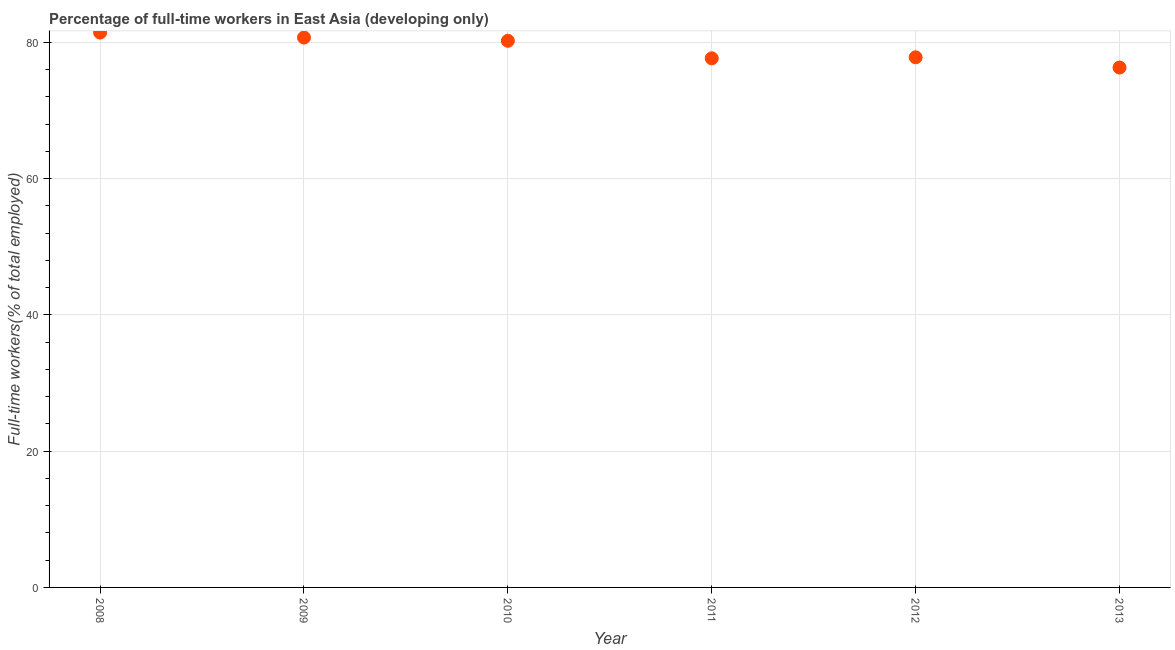What is the percentage of full-time workers in 2009?
Provide a short and direct response. 80.71. Across all years, what is the maximum percentage of full-time workers?
Provide a short and direct response. 81.44. Across all years, what is the minimum percentage of full-time workers?
Keep it short and to the point. 76.31. In which year was the percentage of full-time workers maximum?
Your response must be concise. 2008. In which year was the percentage of full-time workers minimum?
Offer a very short reply. 2013. What is the sum of the percentage of full-time workers?
Your response must be concise. 474.18. What is the difference between the percentage of full-time workers in 2010 and 2011?
Your answer should be compact. 2.57. What is the average percentage of full-time workers per year?
Offer a terse response. 79.03. What is the median percentage of full-time workers?
Keep it short and to the point. 79.03. In how many years, is the percentage of full-time workers greater than 12 %?
Keep it short and to the point. 6. Do a majority of the years between 2013 and 2011 (inclusive) have percentage of full-time workers greater than 68 %?
Keep it short and to the point. No. What is the ratio of the percentage of full-time workers in 2009 to that in 2013?
Your answer should be compact. 1.06. Is the percentage of full-time workers in 2008 less than that in 2013?
Provide a short and direct response. No. Is the difference between the percentage of full-time workers in 2008 and 2011 greater than the difference between any two years?
Keep it short and to the point. No. What is the difference between the highest and the second highest percentage of full-time workers?
Ensure brevity in your answer.  0.73. What is the difference between the highest and the lowest percentage of full-time workers?
Offer a very short reply. 5.13. In how many years, is the percentage of full-time workers greater than the average percentage of full-time workers taken over all years?
Your answer should be very brief. 3. Does the percentage of full-time workers monotonically increase over the years?
Make the answer very short. No. How many dotlines are there?
Your answer should be compact. 1. What is the difference between two consecutive major ticks on the Y-axis?
Offer a terse response. 20. Are the values on the major ticks of Y-axis written in scientific E-notation?
Ensure brevity in your answer.  No. What is the title of the graph?
Your response must be concise. Percentage of full-time workers in East Asia (developing only). What is the label or title of the X-axis?
Provide a succinct answer. Year. What is the label or title of the Y-axis?
Keep it short and to the point. Full-time workers(% of total employed). What is the Full-time workers(% of total employed) in 2008?
Provide a short and direct response. 81.44. What is the Full-time workers(% of total employed) in 2009?
Offer a terse response. 80.71. What is the Full-time workers(% of total employed) in 2010?
Keep it short and to the point. 80.24. What is the Full-time workers(% of total employed) in 2011?
Offer a terse response. 77.66. What is the Full-time workers(% of total employed) in 2012?
Keep it short and to the point. 77.81. What is the Full-time workers(% of total employed) in 2013?
Your response must be concise. 76.31. What is the difference between the Full-time workers(% of total employed) in 2008 and 2009?
Your response must be concise. 0.73. What is the difference between the Full-time workers(% of total employed) in 2008 and 2010?
Your answer should be compact. 1.21. What is the difference between the Full-time workers(% of total employed) in 2008 and 2011?
Your answer should be compact. 3.78. What is the difference between the Full-time workers(% of total employed) in 2008 and 2012?
Your answer should be very brief. 3.63. What is the difference between the Full-time workers(% of total employed) in 2008 and 2013?
Make the answer very short. 5.13. What is the difference between the Full-time workers(% of total employed) in 2009 and 2010?
Offer a terse response. 0.48. What is the difference between the Full-time workers(% of total employed) in 2009 and 2011?
Provide a succinct answer. 3.05. What is the difference between the Full-time workers(% of total employed) in 2009 and 2012?
Make the answer very short. 2.9. What is the difference between the Full-time workers(% of total employed) in 2009 and 2013?
Offer a terse response. 4.4. What is the difference between the Full-time workers(% of total employed) in 2010 and 2011?
Keep it short and to the point. 2.57. What is the difference between the Full-time workers(% of total employed) in 2010 and 2012?
Offer a terse response. 2.42. What is the difference between the Full-time workers(% of total employed) in 2010 and 2013?
Your answer should be very brief. 3.93. What is the difference between the Full-time workers(% of total employed) in 2011 and 2012?
Keep it short and to the point. -0.15. What is the difference between the Full-time workers(% of total employed) in 2011 and 2013?
Your answer should be compact. 1.35. What is the difference between the Full-time workers(% of total employed) in 2012 and 2013?
Offer a very short reply. 1.5. What is the ratio of the Full-time workers(% of total employed) in 2008 to that in 2009?
Your answer should be compact. 1.01. What is the ratio of the Full-time workers(% of total employed) in 2008 to that in 2010?
Provide a succinct answer. 1.01. What is the ratio of the Full-time workers(% of total employed) in 2008 to that in 2011?
Provide a short and direct response. 1.05. What is the ratio of the Full-time workers(% of total employed) in 2008 to that in 2012?
Keep it short and to the point. 1.05. What is the ratio of the Full-time workers(% of total employed) in 2008 to that in 2013?
Provide a succinct answer. 1.07. What is the ratio of the Full-time workers(% of total employed) in 2009 to that in 2011?
Ensure brevity in your answer.  1.04. What is the ratio of the Full-time workers(% of total employed) in 2009 to that in 2013?
Your response must be concise. 1.06. What is the ratio of the Full-time workers(% of total employed) in 2010 to that in 2011?
Keep it short and to the point. 1.03. What is the ratio of the Full-time workers(% of total employed) in 2010 to that in 2012?
Provide a succinct answer. 1.03. What is the ratio of the Full-time workers(% of total employed) in 2010 to that in 2013?
Your response must be concise. 1.05. What is the ratio of the Full-time workers(% of total employed) in 2011 to that in 2012?
Provide a short and direct response. 1. What is the ratio of the Full-time workers(% of total employed) in 2011 to that in 2013?
Give a very brief answer. 1.02. 